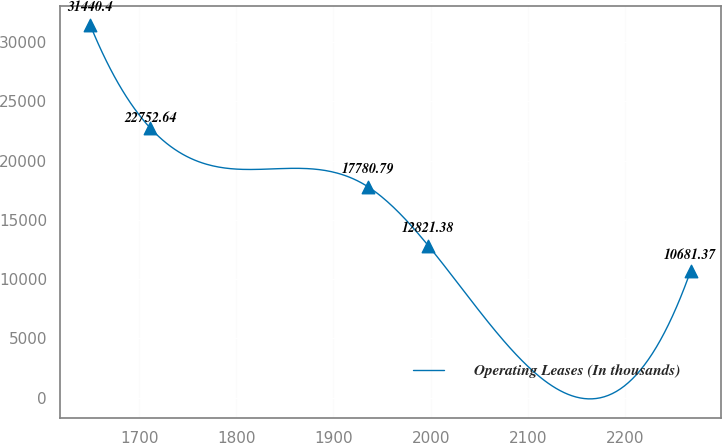<chart> <loc_0><loc_0><loc_500><loc_500><line_chart><ecel><fcel>Operating Leases (In thousands)<nl><fcel>1649.73<fcel>31440.4<nl><fcel>1711.5<fcel>22752.6<nl><fcel>1935.85<fcel>17780.8<nl><fcel>1997.62<fcel>12821.4<nl><fcel>2267.45<fcel>10681.4<nl></chart> 